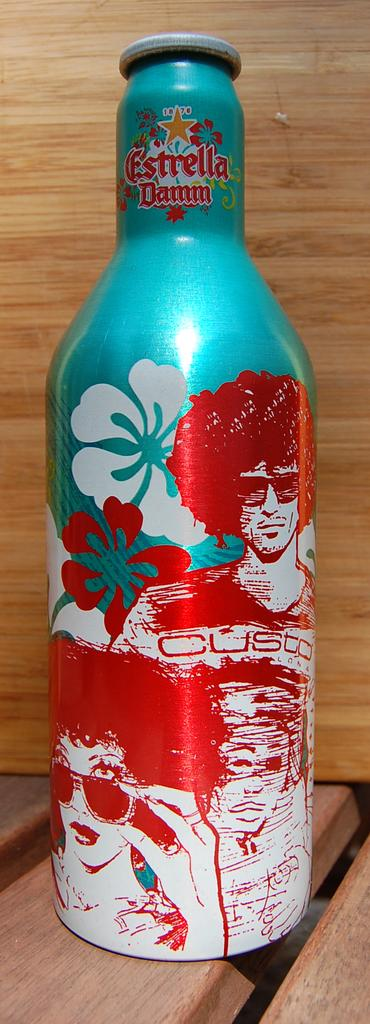<image>
Share a concise interpretation of the image provided. An Estrella drink bottle shows a colorful blue and red tropical scene. 